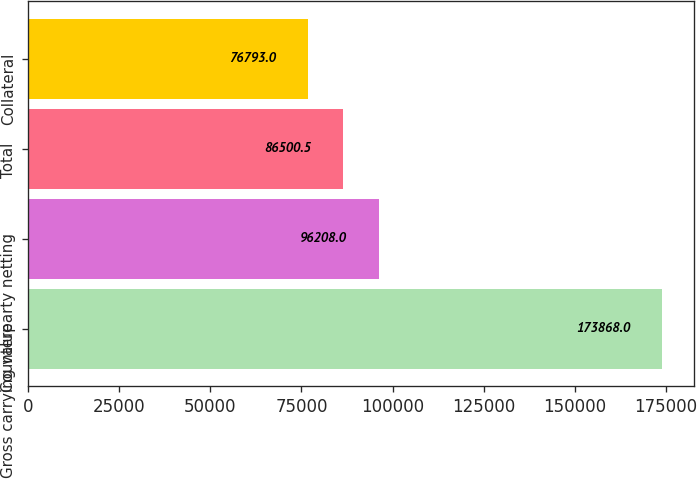Convert chart to OTSL. <chart><loc_0><loc_0><loc_500><loc_500><bar_chart><fcel>Gross carrying value<fcel>Counterparty netting<fcel>Total<fcel>Collateral<nl><fcel>173868<fcel>96208<fcel>86500.5<fcel>76793<nl></chart> 